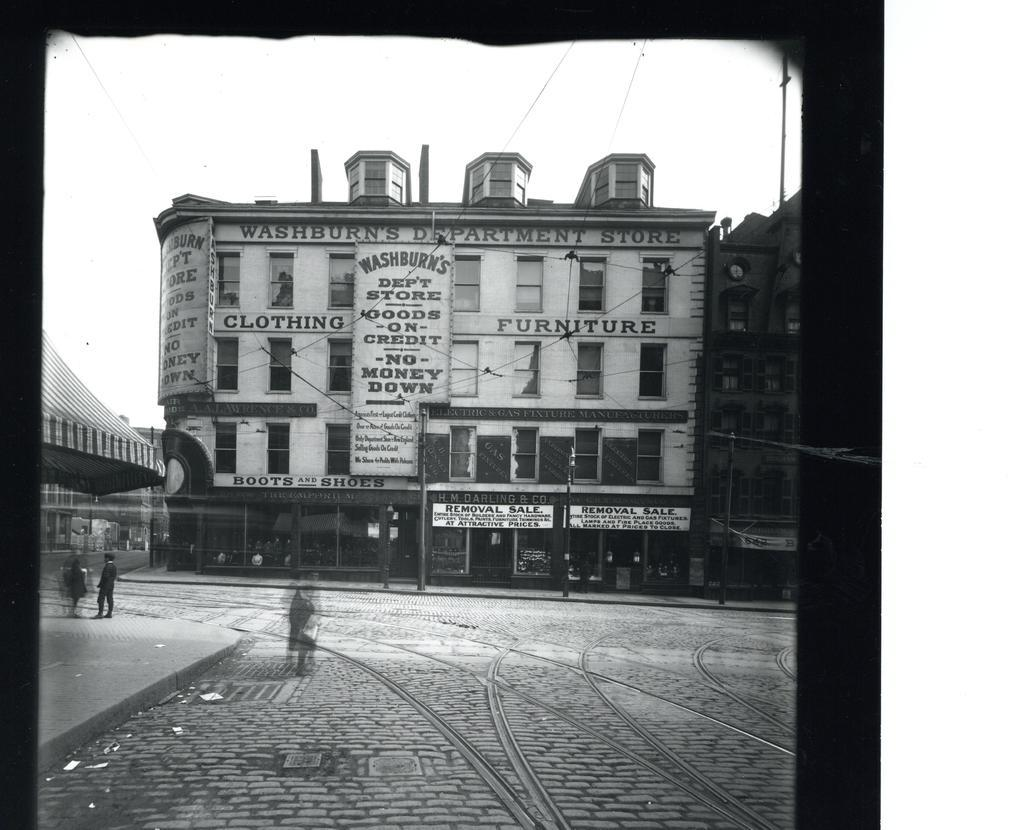What is the color scheme of the image? The image is black and white. What type of structures are present in the image? There are buildings with boards in the image. Can you describe the people in the image? There are people in the image. What architectural features can be seen in the image? There are windows and poles in the image. What is visible in the background of the image? The sky is visible in the background of the image. What type of basin can be seen in the image? There is no basin present in the image. What activity are the people engaged in within the image? The provided facts do not specify any particular activity that the people are engaged in. 